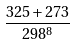<formula> <loc_0><loc_0><loc_500><loc_500>\frac { 3 2 5 + 2 7 3 } { 2 9 8 ^ { 8 } }</formula> 